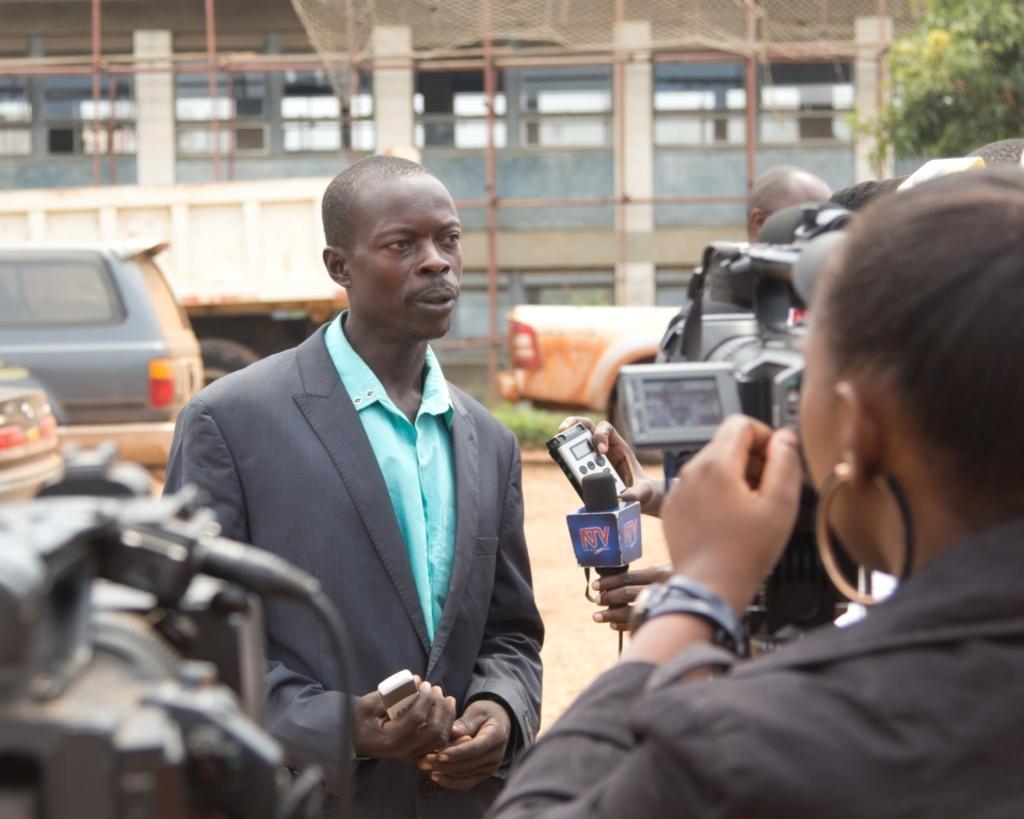Could you give a brief overview of what you see in this image? On the left at the bottom corner we can see a camera and on the right there are few persons holding cameras,mile and a recorder in their hands. In the middle we can see a man standing and holding a mobile in his hands. In the background there are vehicles on the road,poles,net and a tree and some other objects. 